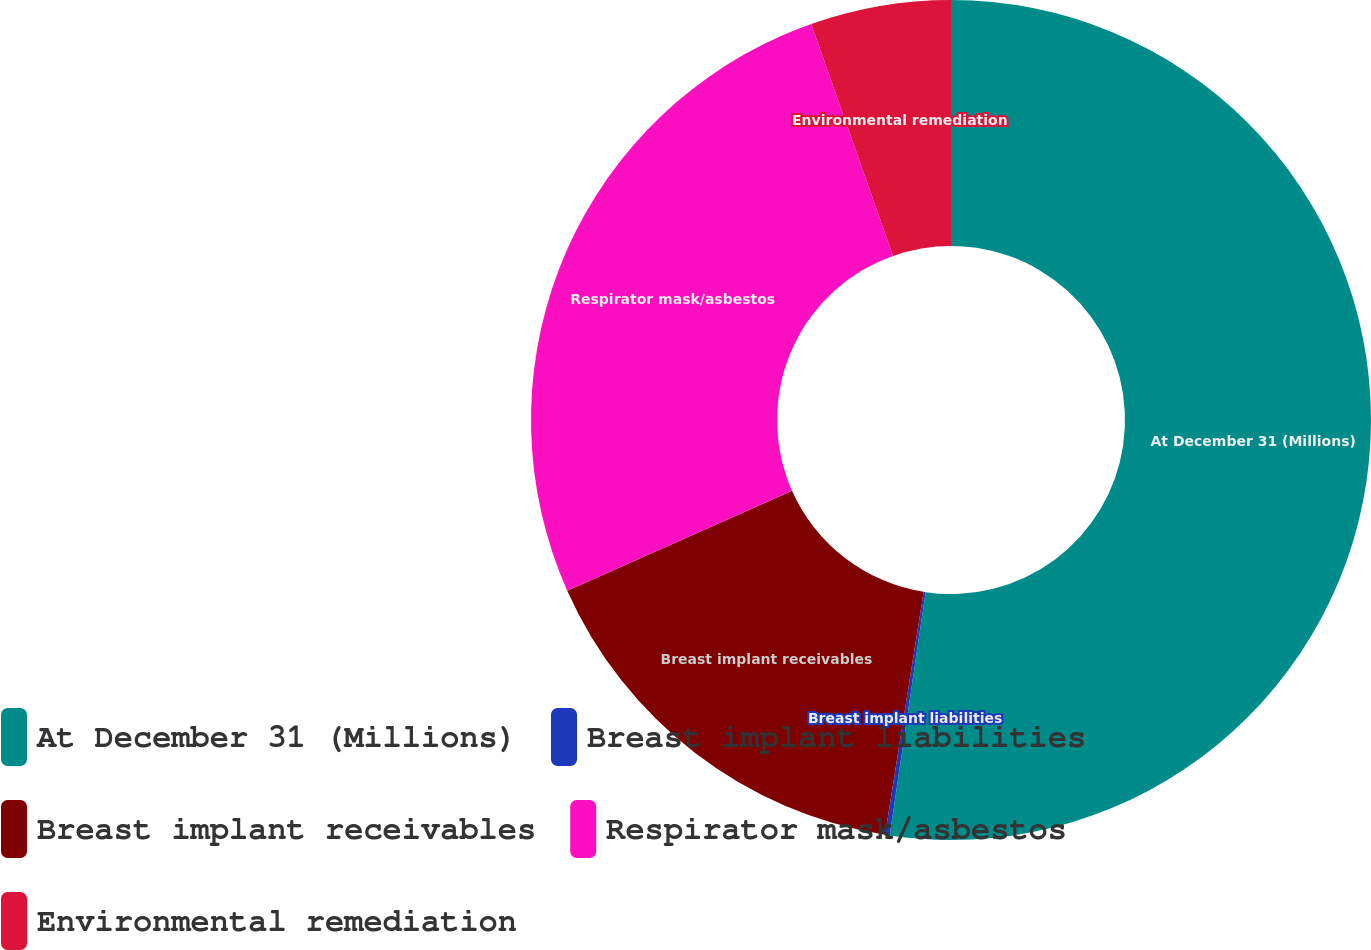<chart> <loc_0><loc_0><loc_500><loc_500><pie_chart><fcel>At December 31 (Millions)<fcel>Breast implant liabilities<fcel>Breast implant receivables<fcel>Respirator mask/asbestos<fcel>Environmental remediation<nl><fcel>52.33%<fcel>0.18%<fcel>15.83%<fcel>26.26%<fcel>5.4%<nl></chart> 